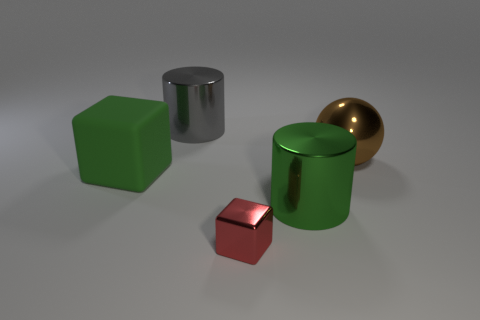Subtract 1 cylinders. How many cylinders are left? 1 Add 2 green blocks. How many objects exist? 7 Subtract all green cubes. How many cubes are left? 1 Subtract all balls. How many objects are left? 4 Subtract all blue balls. Subtract all red cylinders. How many balls are left? 1 Subtract all cyan cylinders. How many green cubes are left? 1 Subtract all brown metallic spheres. Subtract all tiny red objects. How many objects are left? 3 Add 2 tiny red metal cubes. How many tiny red metal cubes are left? 3 Add 5 red shiny things. How many red shiny things exist? 6 Subtract 0 purple balls. How many objects are left? 5 